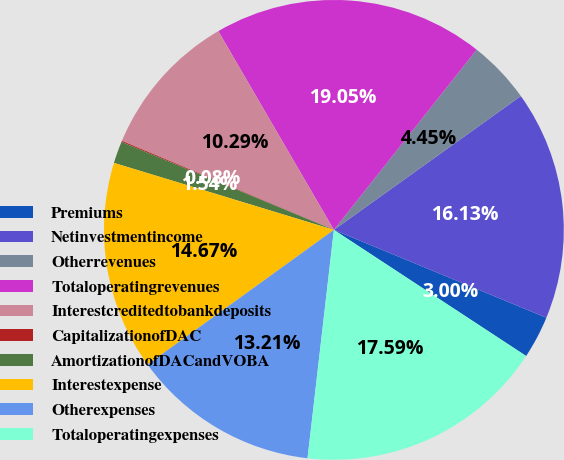Convert chart to OTSL. <chart><loc_0><loc_0><loc_500><loc_500><pie_chart><fcel>Premiums<fcel>Netinvestmentincome<fcel>Otherrevenues<fcel>Totaloperatingrevenues<fcel>Interestcreditedtobankdeposits<fcel>CapitalizationofDAC<fcel>AmortizationofDACandVOBA<fcel>Interestexpense<fcel>Otherexpenses<fcel>Totaloperatingexpenses<nl><fcel>3.0%<fcel>16.13%<fcel>4.45%<fcel>19.05%<fcel>10.29%<fcel>0.08%<fcel>1.54%<fcel>14.67%<fcel>13.21%<fcel>17.59%<nl></chart> 